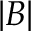Convert formula to latex. <formula><loc_0><loc_0><loc_500><loc_500>| B |</formula> 